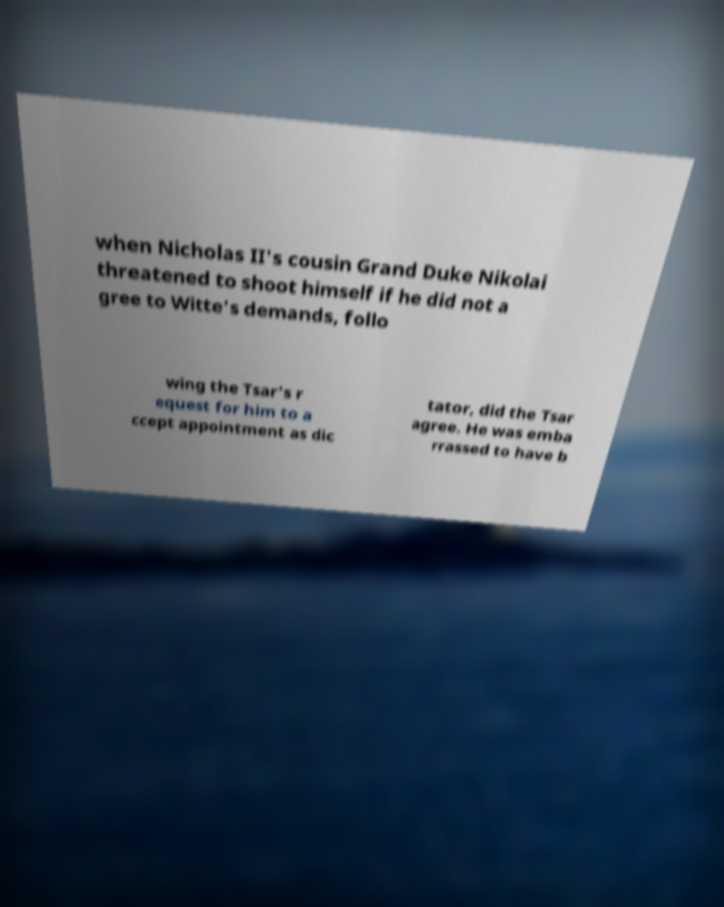Please identify and transcribe the text found in this image. when Nicholas II's cousin Grand Duke Nikolai threatened to shoot himself if he did not a gree to Witte's demands, follo wing the Tsar's r equest for him to a ccept appointment as dic tator, did the Tsar agree. He was emba rrassed to have b 